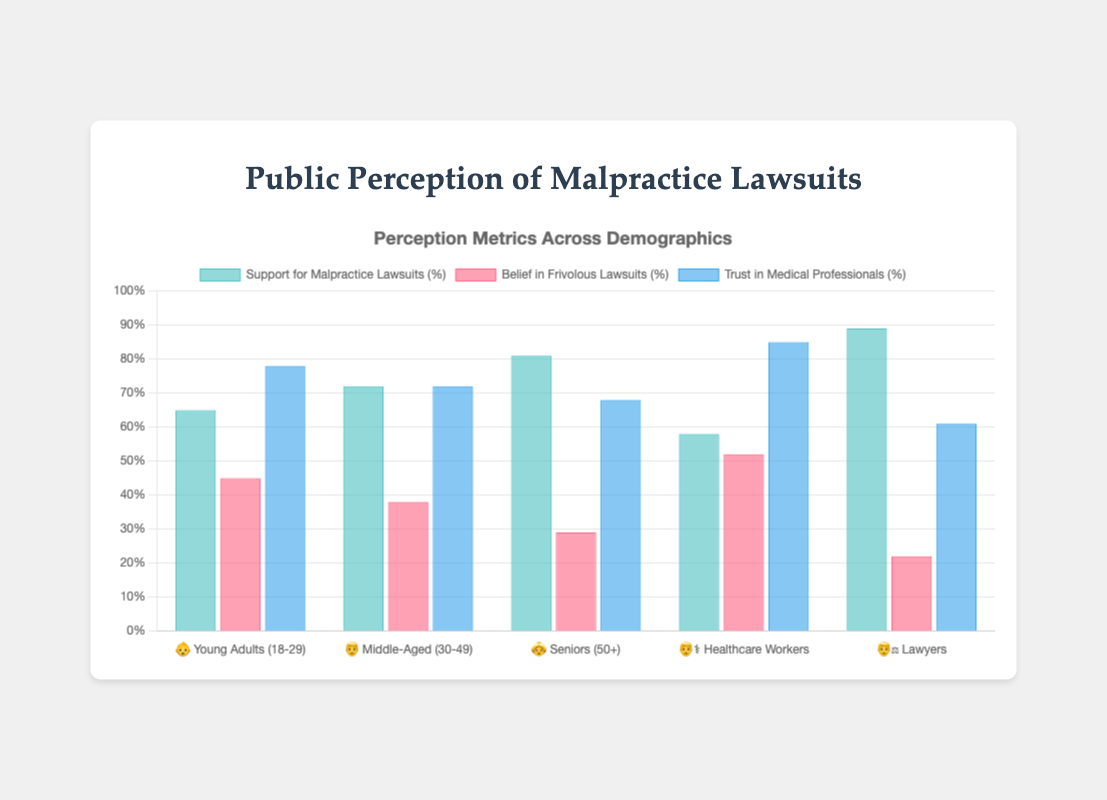What is the support percentage for malpractice lawsuits by Middle-Aged adults? Look for the bar representing "Support for Malpractice Lawsuits %" for the demographic group labeled "👨 Middle-Aged (30-49)". The height of the bar indicates the support percentage.
Answer: 72% Which demographic shows the highest trust in medical professionals? Compare the heights of the bars labeled "Trust in Medical Professionals %" across all demographic groups. The tallest bar represents the highest trust percentage.
Answer: Healthcare Workers What is the difference in belief in frivolous lawsuits between Young Adults and Lawyers? Identify the bars labeled "Belief in Frivolous Lawsuits %" for both "👶 Young Adults" and "👨‍⚖️ Lawyers". Subtract the value for Lawyers from the value for Young Adults.
Answer: 23% How does the support for malpractice lawsuits by Lawyers compare to Seniors? Locate the bars for "Support for Malpractice Lawsuits %" under "👨‍⚖️ Lawyers" and "👵 Seniors". Determine which bar is taller to find out who has higher support.
Answer: Lawyers have higher support What is the average trust in medical professionals across all demographic groups? Sum the trust percentages for all demographic groups: (78 + 72 + 68 + 85 + 61). Then divide by the number of groups (5).
Answer: 72.8% Which demographic group has the least support for malpractice lawsuits? Compare the heights of all the bars under "Support for Malpractice Lawsuits %". The shortest bar indicates the least support.
Answer: Healthcare Workers What is the combined percentage of belief in frivolous lawsuits for Young Adults and Healthcare Workers? Add the values for "Belief in Frivolous Lawsuits %" from "👶 Young Adults" and "👨‍⚕️ Healthcare Workers".
Answer: 97% Which two demographic groups have the closest values in terms of trust in medical professionals? Compare the heights of the bars under "Trust in Medical Professionals %" to find two bars with the smallest difference in height.
Answer: Young Adults and Middle-Aged How much more support for malpractice lawsuits do Seniors have compared to Healthcare Workers? Subtract the value for "Support for Malpractice Lawsuits %" from "👨‍⚕️ Healthcare Workers" from that of "👵 Seniors".
Answer: 23% 